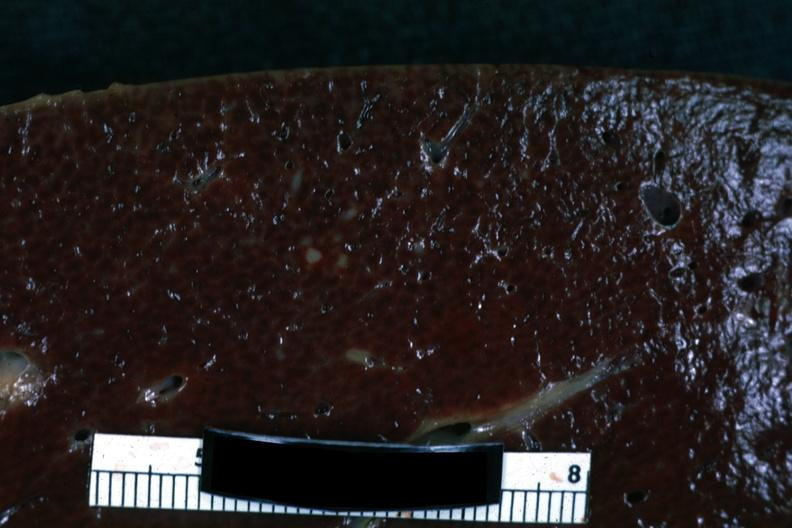does exact cause show cut surface with focal infiltrate?
Answer the question using a single word or phrase. No 